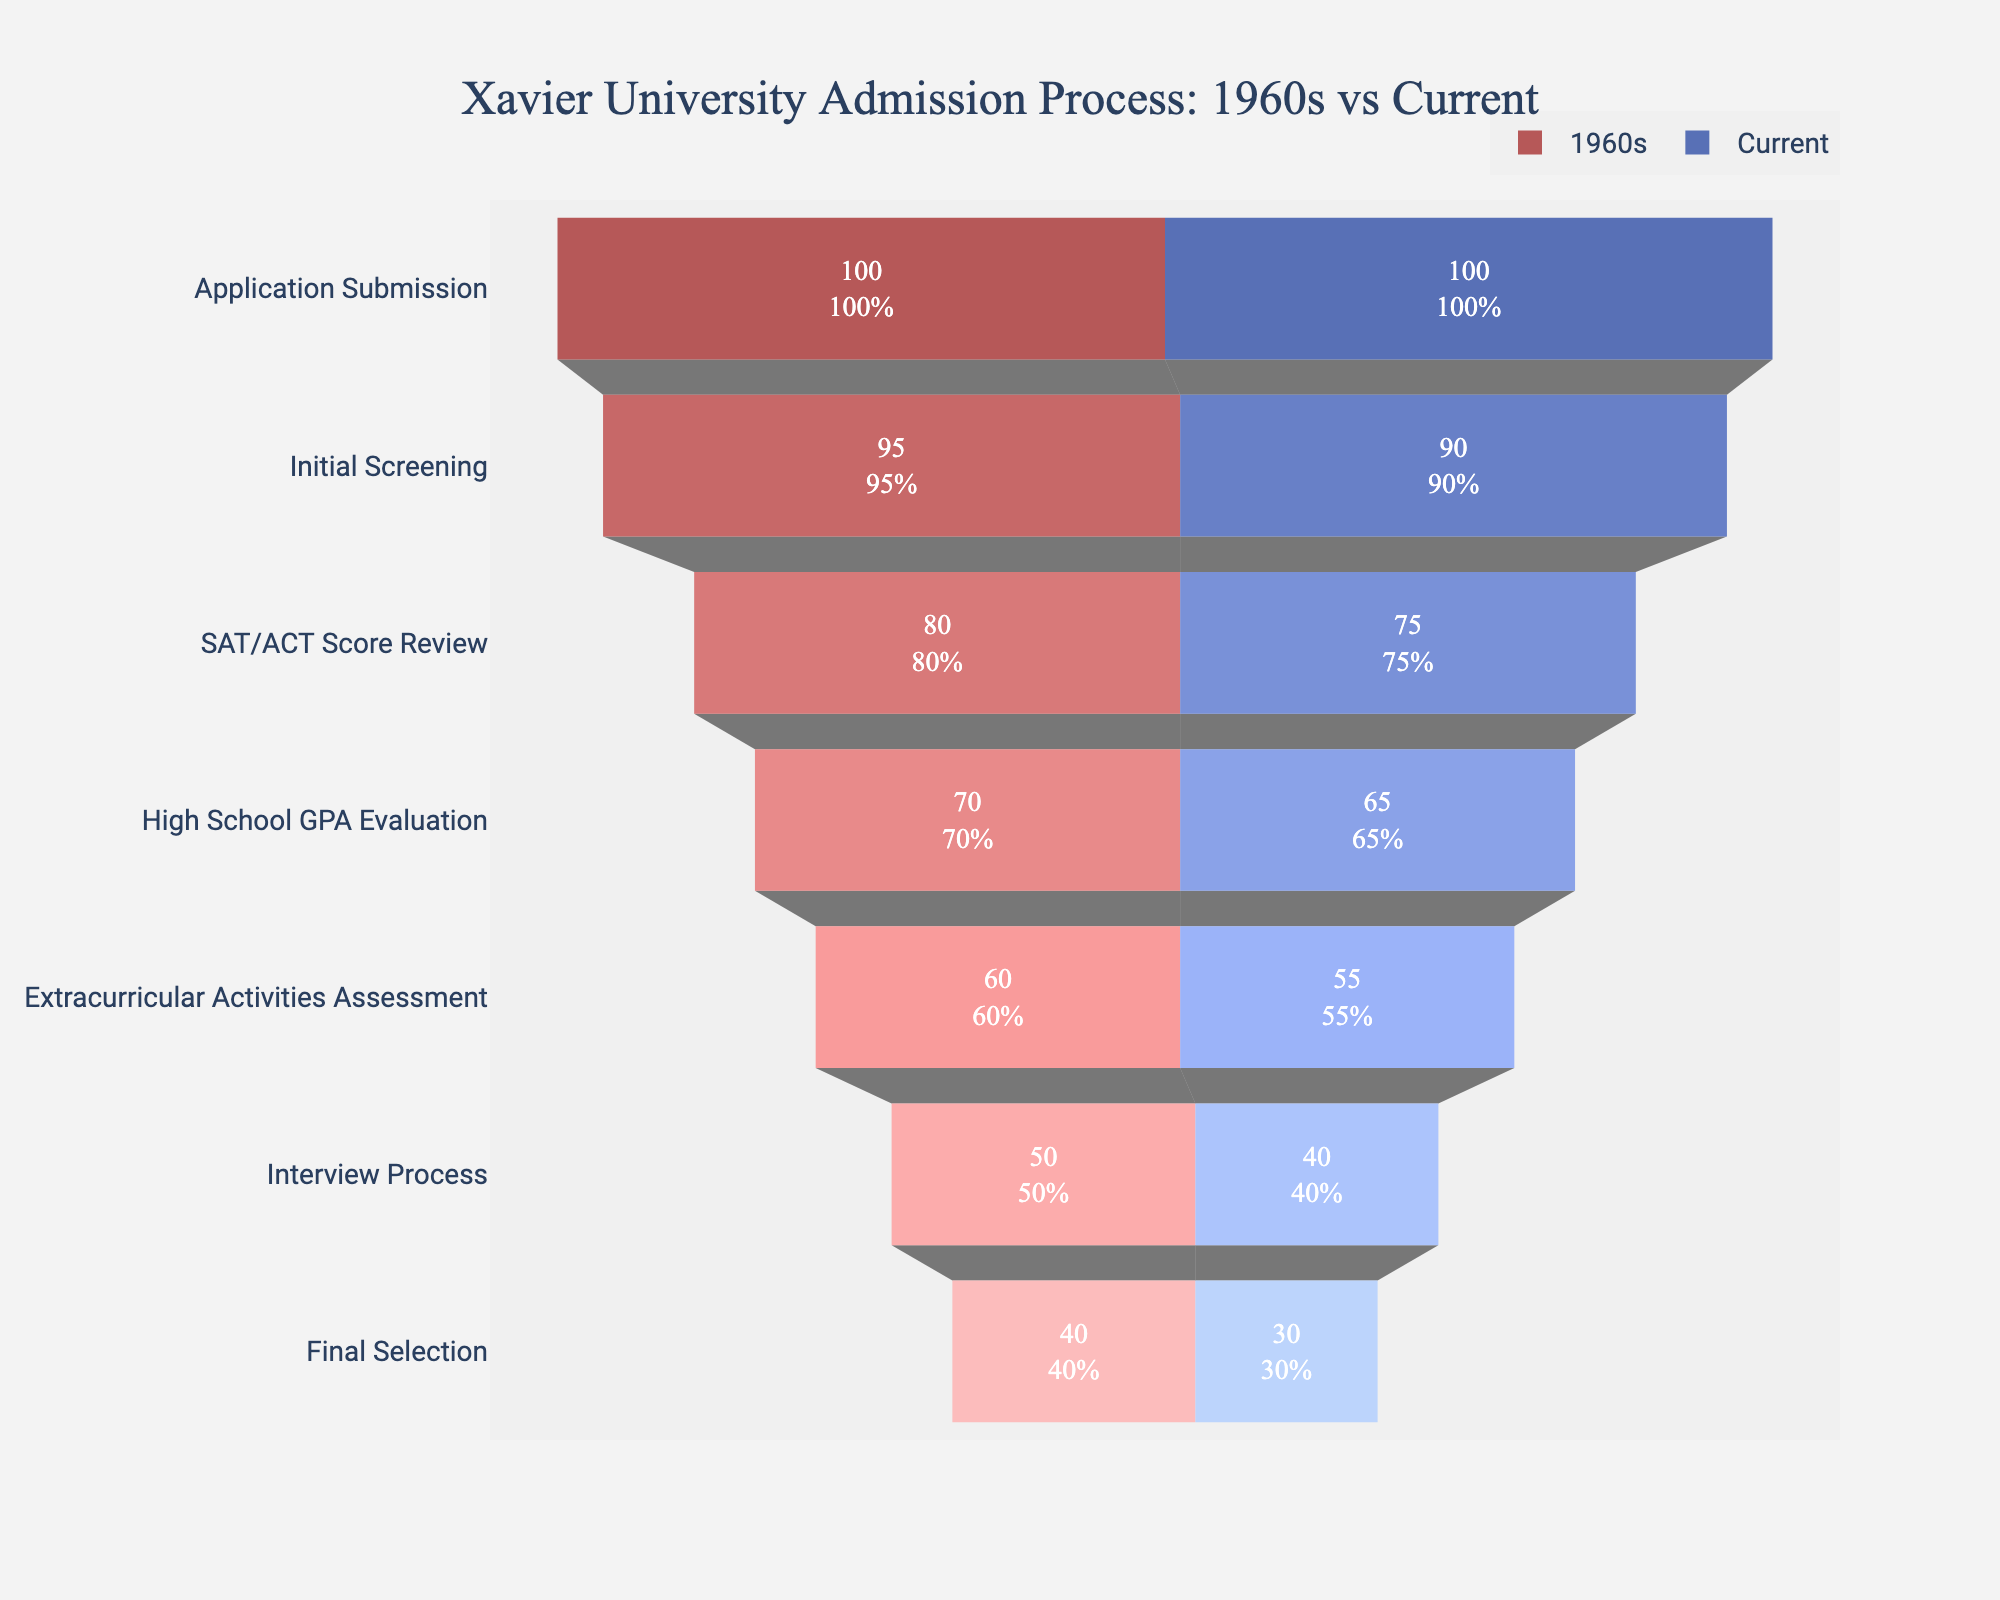What is the title of the chart? The title is often placed at the top center of the chart. From the given code, we know the title is "Xavier University Admission Process: 1960s vs Current".
Answer: Xavier University Admission Process: 1960s vs Current What are the colors used to represent the 1960s and current acceptance rates? The code specifies different colors for each decade, with the 1960s using varying shades of red and the current rates using shades of blue.
Answer: Red for the 1960s, Blue for Current At which stage is the difference in acceptance rate highest between the two periods? Observing the stages, the largest difference is seen during the Interview Process, where the acceptance rate drops from 50% in the 1960s to 40% currently.
Answer: Interview Process What is the acceptance rate for the Final Selection stage in the current day? The final selection would be at the bottom of the funnel for the current day data. The acceptance rate here is 30%.
Answer: 30% How does the acceptance rate at the Initial Screening stage compare between the 1960s and current day? Comparing the acceptance rates at this stage, the rate was 95% in the 1960s and 90% currently.
Answer: 1960s: 95%, Current: 90% What stage shows the least drop in acceptance rates between the 1960s and current? The least drop is seen at the High School GPA Evaluation stage, with a decrease from 70% to 65%, a difference of only 5%.
Answer: High School GPA Evaluation How does the overall trend of acceptance rates from Application Submission to Final Selection compare between the 1960s and current day? Both periods show a decreasing trend across all stages, but the current day shows a steeper decline in acceptance rates compared to the 1960s.
Answer: Steeper decline currently What is the acceptance rate at the Extracurricular Activities Assessment stage in the 1960s vs the current day? The 1960s had an acceptance rate of 60%, whereas the current day acceptance rate is at 55% for this stage.
Answer: 1960s: 60%, Current: 55% Calculate the average acceptance rate across all stages for both the 1960s and the current day. For the 1960s: (100 + 95 + 80 + 70 + 60 + 50 + 40) / 7 = 70.71%. For the current day: (100 + 90 + 75 + 65 + 55 + 40 + 30) / 7 = 65.
Answer: 1960s: 70.71%, Current: 65% Which stage indicates the most severe drop in acceptance rate progression for the current scenario compared to the 1960s? The Interview Process shows the most severe drop, moving from 50% in the 1960s to 40% currently, indicating stricter criteria.
Answer: Interview Process 